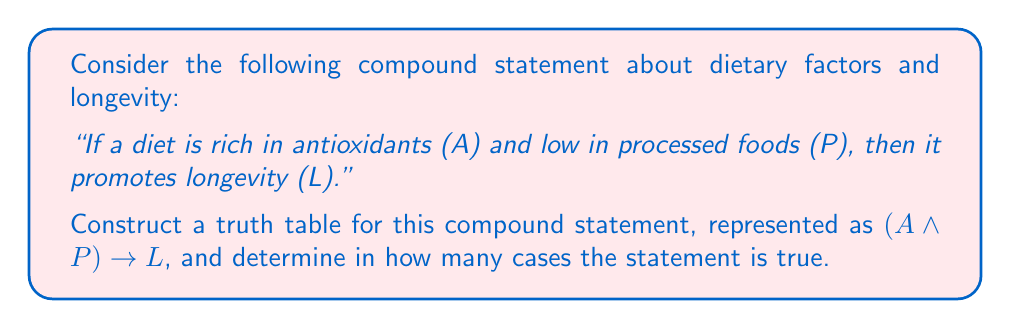Give your solution to this math problem. Let's approach this step-by-step:

1) First, we need to identify the atomic propositions:
   A: The diet is rich in antioxidants
   P: The diet is low in processed foods
   L: The diet promotes longevity

2) The compound statement is: $(A \land P) \rightarrow L$

3) To construct the truth table, we need to consider all possible combinations of truth values for A, P, and L. There are $2^3 = 8$ possible combinations.

4) Let's create the truth table:

   | A | P | L | A ∧ P | (A ∧ P) → L |
   |---|---|---|-------|-------------|
   | T | T | T |   T   |      T      |
   | T | T | F |   T   |      F      |
   | T | F | T |   F   |      T      |
   | T | F | F |   F   |      T      |
   | F | T | T |   F   |      T      |
   | F | T | F |   F   |      T      |
   | F | F | T |   F   |      T      |
   | F | F | F |   F   |      T      |

5) To fill in the "A ∧ P" column, we use the truth table for AND (∧):
   - T ∧ T = T
   - T ∧ F = F
   - F ∧ T = F
   - F ∧ F = F

6) For the last column, we use the truth table for implication (→):
   - T → T = T
   - T → F = F
   - F → T = T
   - F → F = T

7) Now, we can count in how many cases the compound statement $(A \land P) \rightarrow L$ is true. Looking at the last column, we see that it's true in 7 out of 8 cases.

This result suggests that the statement "If a diet is rich in antioxidants and low in processed foods, then it promotes longevity" is true in most scenarios according to this logical analysis. However, it's important to note that this is a simplified logical model and does not necessarily reflect the complex realities of nutrition and longevity.
Answer: The compound statement $(A \land P) \rightarrow L$ is true in 7 out of 8 cases in the truth table. 